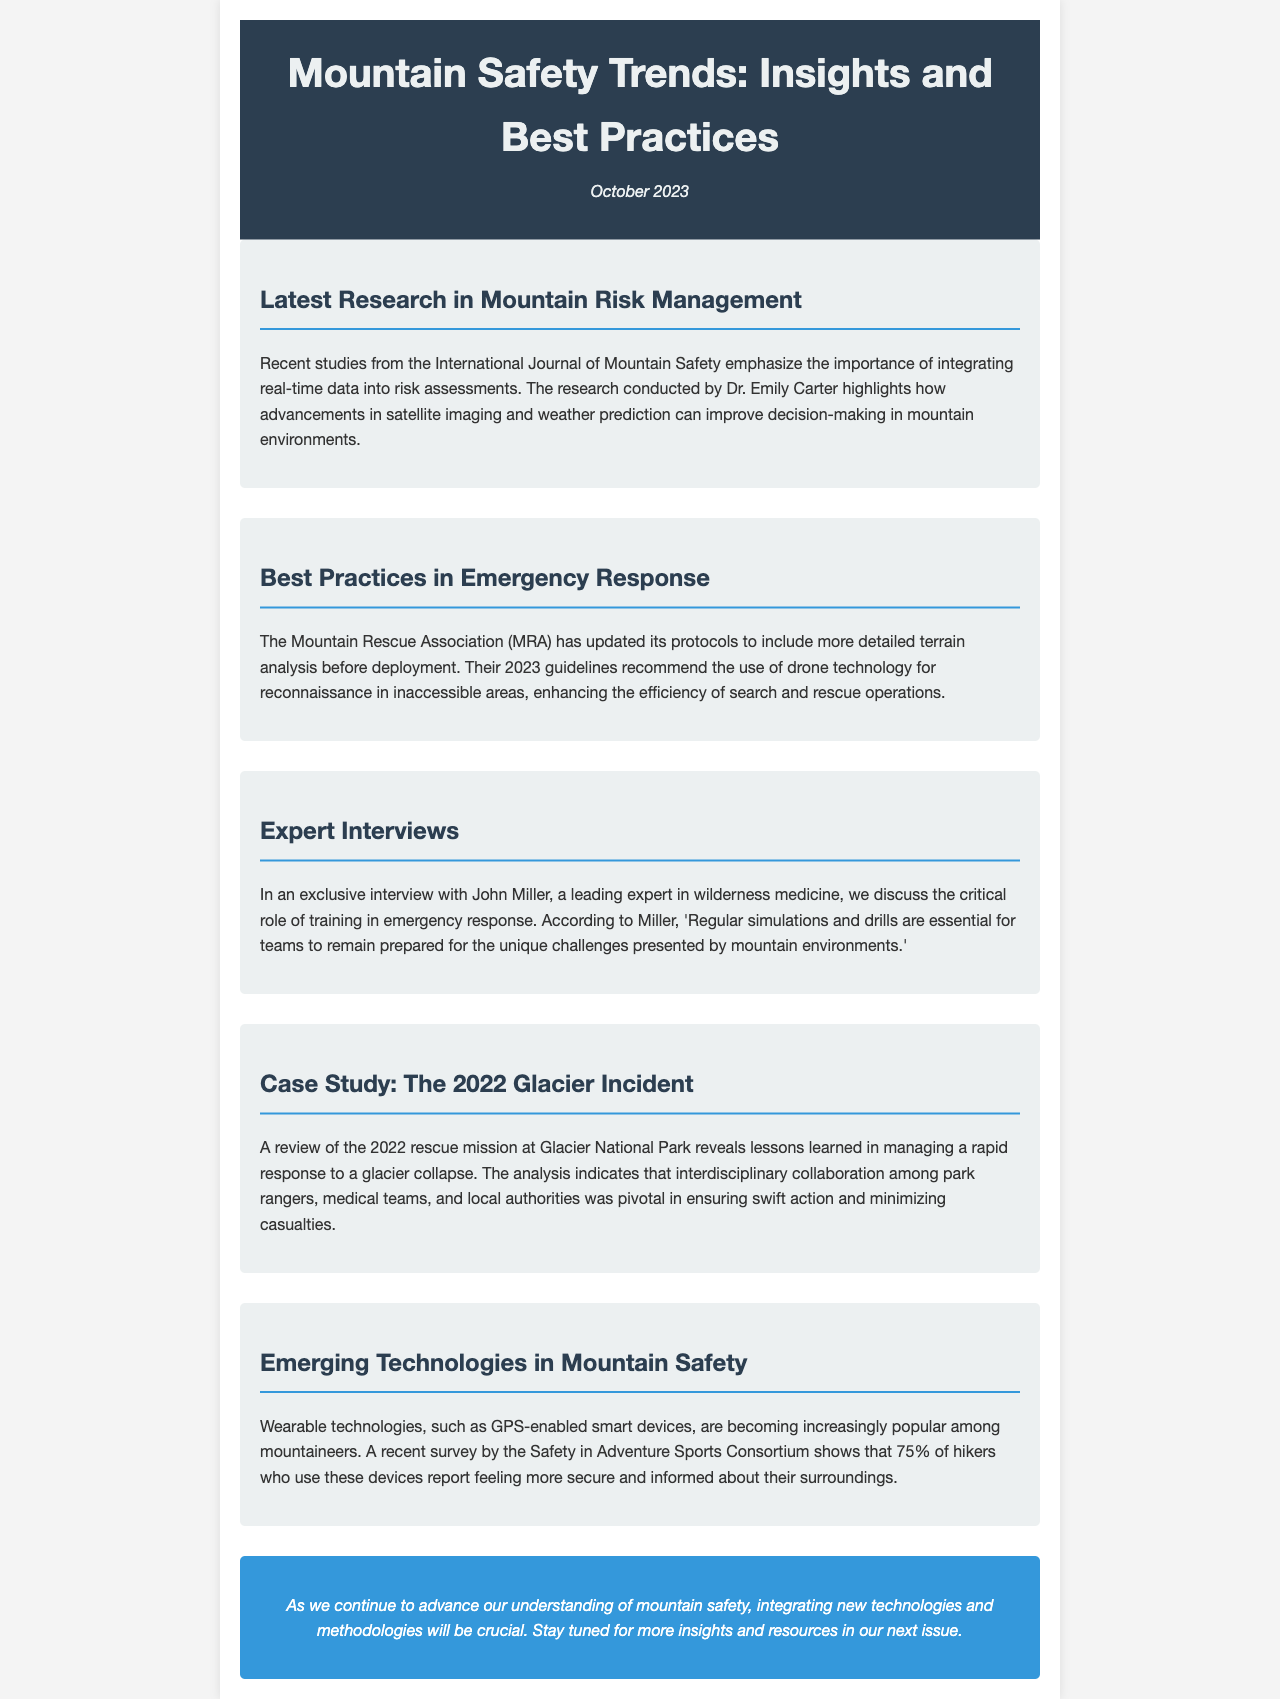What is the publication date of the newsletter? The publication date is listed at the top of the newsletter under the header section.
Answer: October 2023 Who conducted the recent studies mentioned in the newsletter? The studies are attributed to Dr. Emily Carter as mentioned in the section discussing the latest research.
Answer: Dr. Emily Carter What new technology is recommended by the Mountain Rescue Association for reconnaissance? The newsletter specifies the use of a certain technology in emergency response practices.
Answer: Drone technology According to John Miller, what is essential for teams in emergency response? This information is presented in the expert interview section, focusing on the training aspect.
Answer: Regular simulations and drills What percentage of hikers using GPS-enabled devices feel more secure? The newsletter provides a statistic from a recent survey regarding the use of these devices.
Answer: 75% What event does the case study in the newsletter highlight? The title of the section indicates the specific incident reviewed for lessons learned in rescue operations.
Answer: The 2022 Glacier Incident In what journal was the recent research published? The newsletter indicates the publication associated with the mentioned studies on mountain safety.
Answer: International Journal of Mountain Safety What is the conclusion of the newsletter about mountain safety? The final section encapsulates the newsletter's outlook on future developments in mountain safety practices.
Answer: Integrating new technologies and methodologies will be crucial 